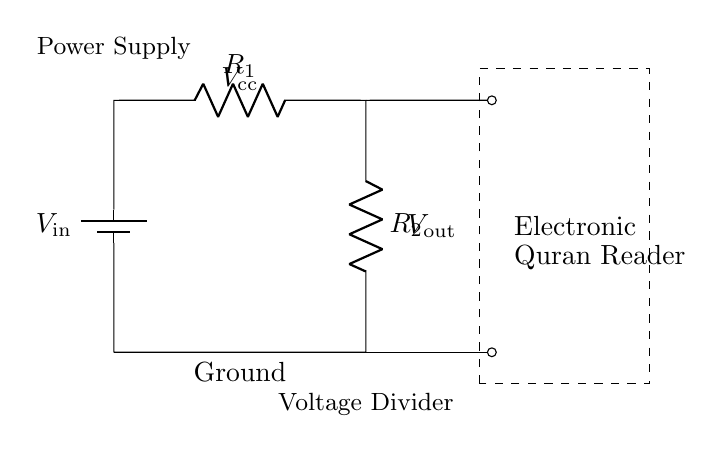What is the input voltage of the circuit? The input voltage, labeled as \(V_\text{in}\), is represented at the battery in the circuit diagram. It shows the power supply connected to the voltage divider.
Answer: \(V_\text{in}\) What components are used in this voltage divider? The circuit includes two resistors, \(R_1\) and \(R_2\), which are essential in forming the voltage divider, and a power supply, represented by the battery, that provides the input voltage.
Answer: \(R_1\), \(R_2\) What does \(V_\text{out}\) represent? \(V_\text{out}\) is the output voltage across the second resistor, which can be calculated using the voltage divider rule. It is labeled in the diagram indicating where the power is supplied to the load, in this case, the electronic Quran reader.
Answer: Output voltage How is the output voltage calculated in this circuit? The output voltage can be calculated using the voltage divider formula \( V_\text{out} = \frac{R_2}{R_1 + R_2} \times V_\text{in} \). This formula shows how the input voltage is divided across the resistors based on their resistance values.
Answer: Using the voltage divider formula What will happen if one of the resistors is removed? Removing either resistor would disturb the voltage division, potentially providing a different voltage than intended to the Quran reader, which may lead to malfunction. The entire function of the voltage divider depends on the presence of both resistors.
Answer: Voltage division failure What is the ground reference in this circuit? The ground reference is marked at the bottom of the circuit diagram, indicating the point from which voltages are measured. It acts as the common return path for electric current.
Answer: Ground What is the purpose of the dashed rectangle in the circuit diagram? The dashed rectangle encompasses the electronic Quran reader, showing that it is the load being powered by the output voltage \(V_\text{out}\) provided by the voltage divider.
Answer: Encloses the load 